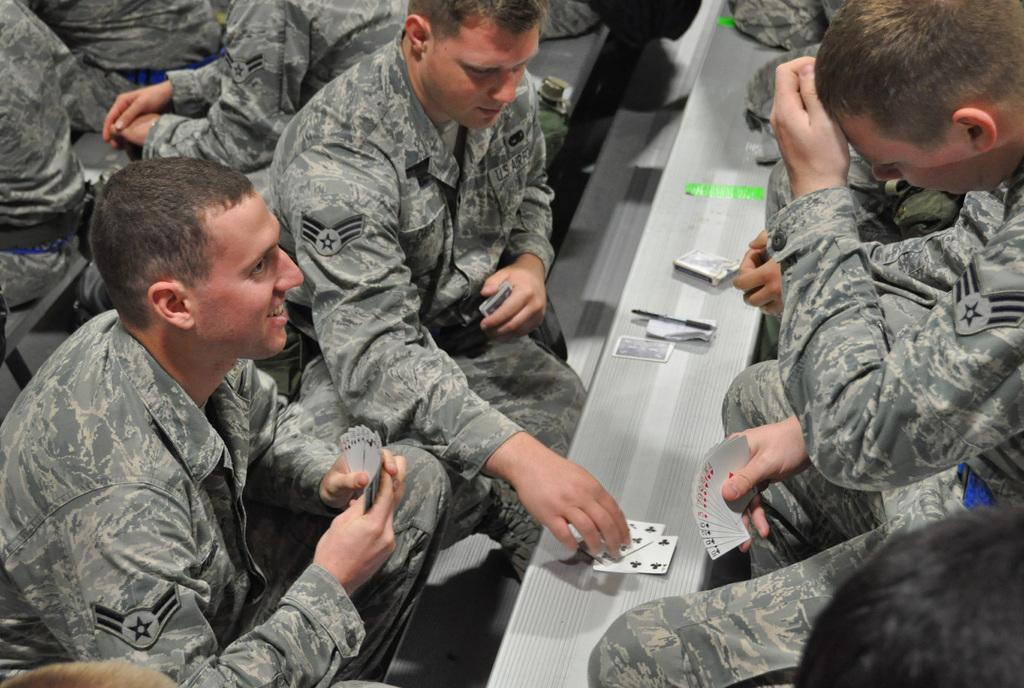Who is present in the image? There are people in the image. What are the people doing in the image? The people are sitting on benches and playing cards. What type of fuel is being used by the woman in the image? There is no woman present in the image, and no fuel is being used. 